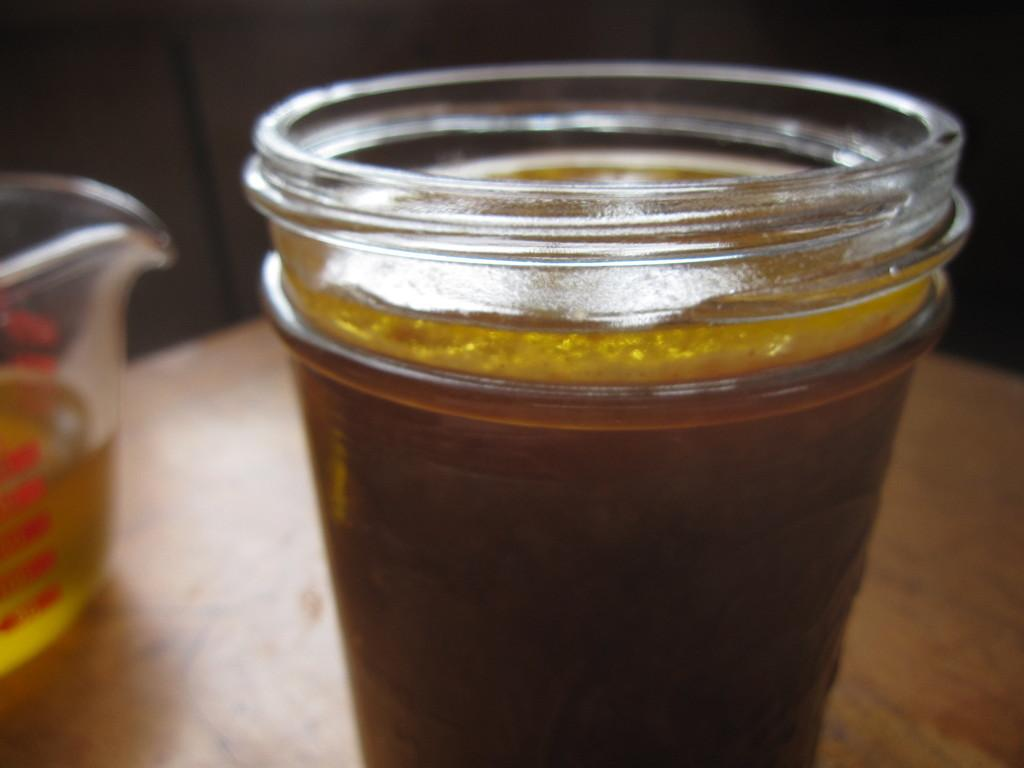What type of furniture is present in the image? There is a table in the image. How many containers are on the table? There are two containers on the table. What are the containers holding? The containers hold a liquid. Where is the house located in the image? There is no house present in the image. Can you describe the duck that is swimming in the liquid? There is no duck present in the image; the containers hold a liquid, but there is no indication of a duck or any other animal. 